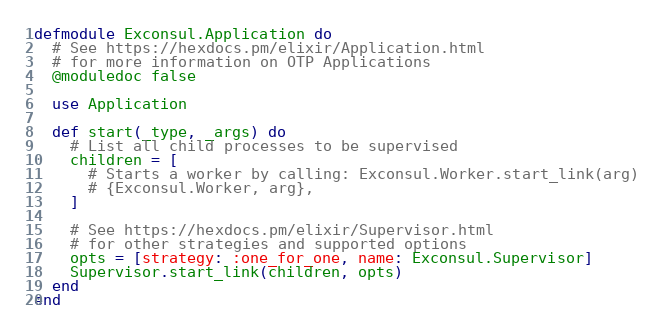<code> <loc_0><loc_0><loc_500><loc_500><_Elixir_>defmodule Exconsul.Application do
  # See https://hexdocs.pm/elixir/Application.html
  # for more information on OTP Applications
  @moduledoc false

  use Application

  def start(_type, _args) do
    # List all child processes to be supervised
    children = [
      # Starts a worker by calling: Exconsul.Worker.start_link(arg)
      # {Exconsul.Worker, arg},
    ]

    # See https://hexdocs.pm/elixir/Supervisor.html
    # for other strategies and supported options
    opts = [strategy: :one_for_one, name: Exconsul.Supervisor]
    Supervisor.start_link(children, opts)
  end
end
</code> 